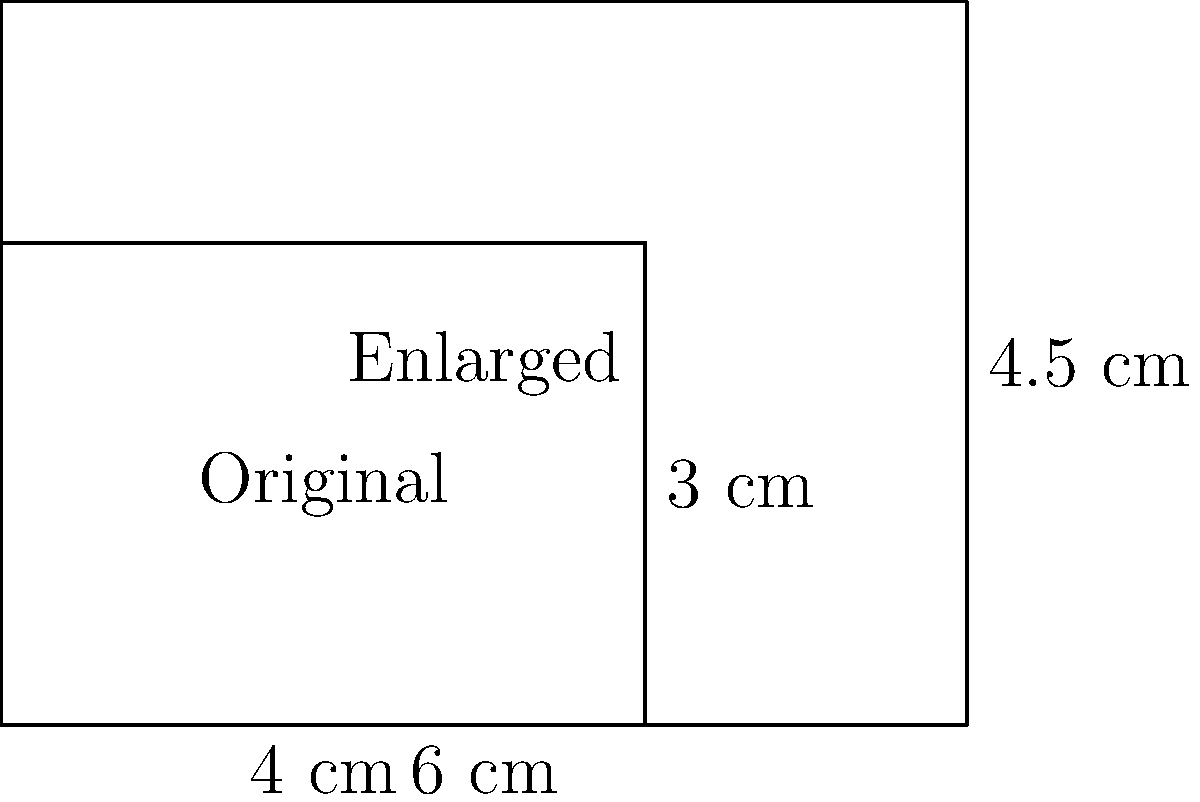As a security guard, you need to enlarge a rectangular security badge design for better visibility. The original badge measures 4 cm by 3 cm, and the enlarged version measures 6 cm by 4.5 cm. What is the scale factor used for this enlargement? To determine the scale factor, we need to compare the dimensions of the enlarged badge to the original badge. We can do this by dividing the new dimensions by the original dimensions:

1. For the width:
   $\frac{\text{New width}}{\text{Original width}} = \frac{6 \text{ cm}}{4 \text{ cm}} = 1.5$

2. For the height:
   $\frac{\text{New height}}{\text{Original height}} = \frac{4.5 \text{ cm}}{3 \text{ cm}} = 1.5$

We can see that both the width and height have been scaled by the same factor of 1.5. This is important because a uniform scale factor maintains the proportions of the original design.

To verify, we can check if multiplying the original dimensions by 1.5 gives us the new dimensions:

Width: $4 \text{ cm} \times 1.5 = 6 \text{ cm}$
Height: $3 \text{ cm} \times 1.5 = 4.5 \text{ cm}$

These match the given dimensions of the enlarged badge, confirming that 1.5 is indeed the correct scale factor.
Answer: 1.5 